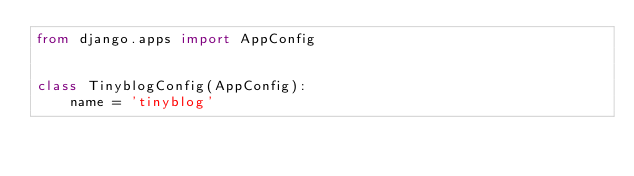<code> <loc_0><loc_0><loc_500><loc_500><_Python_>from django.apps import AppConfig


class TinyblogConfig(AppConfig):
    name = 'tinyblog'
</code> 